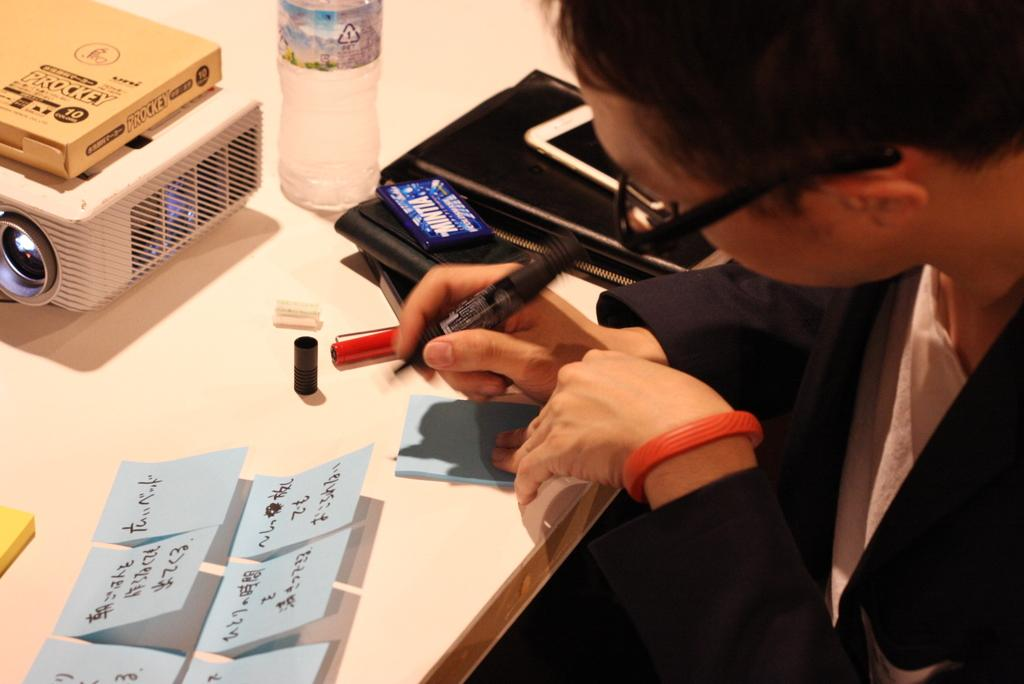Who or what is on the right side of the image? There is a person on the right side of the image. What can be seen on the table in the image? There are objects on a table in the image. What type of head is visible on the person in the image? There is no specific detail about the person's head in the image, so it cannot be determined from the image. 